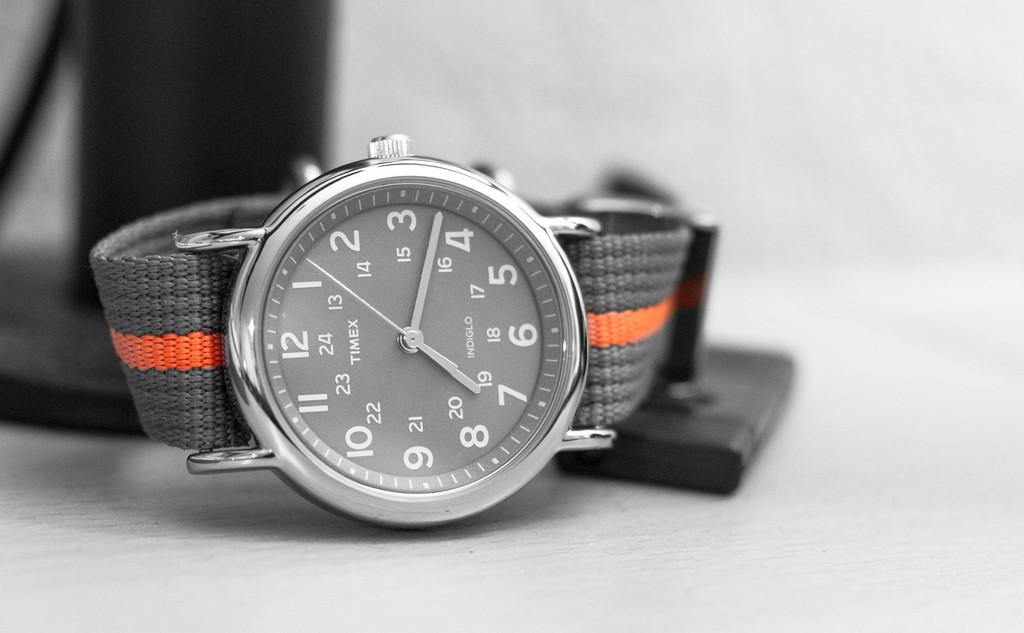Provide a one-sentence caption for the provided image. An analog Timex watch with a grey and orange band. 